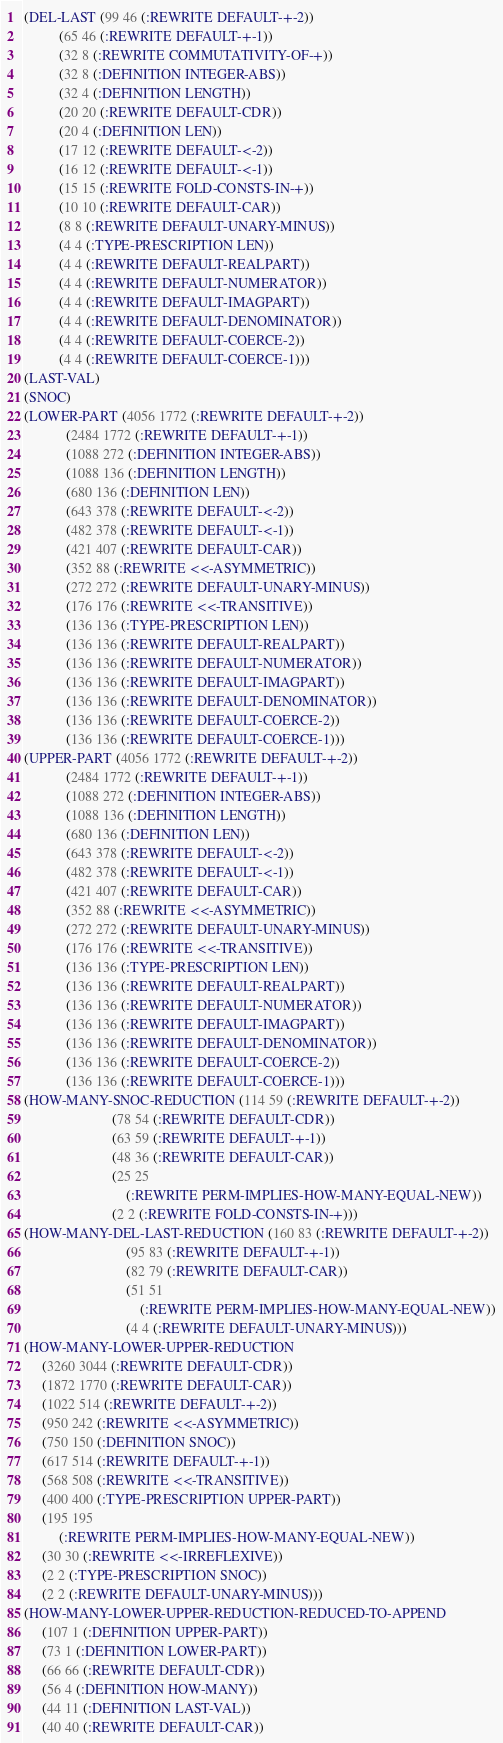Convert code to text. <code><loc_0><loc_0><loc_500><loc_500><_Lisp_>(DEL-LAST (99 46 (:REWRITE DEFAULT-+-2))
          (65 46 (:REWRITE DEFAULT-+-1))
          (32 8 (:REWRITE COMMUTATIVITY-OF-+))
          (32 8 (:DEFINITION INTEGER-ABS))
          (32 4 (:DEFINITION LENGTH))
          (20 20 (:REWRITE DEFAULT-CDR))
          (20 4 (:DEFINITION LEN))
          (17 12 (:REWRITE DEFAULT-<-2))
          (16 12 (:REWRITE DEFAULT-<-1))
          (15 15 (:REWRITE FOLD-CONSTS-IN-+))
          (10 10 (:REWRITE DEFAULT-CAR))
          (8 8 (:REWRITE DEFAULT-UNARY-MINUS))
          (4 4 (:TYPE-PRESCRIPTION LEN))
          (4 4 (:REWRITE DEFAULT-REALPART))
          (4 4 (:REWRITE DEFAULT-NUMERATOR))
          (4 4 (:REWRITE DEFAULT-IMAGPART))
          (4 4 (:REWRITE DEFAULT-DENOMINATOR))
          (4 4 (:REWRITE DEFAULT-COERCE-2))
          (4 4 (:REWRITE DEFAULT-COERCE-1)))
(LAST-VAL)
(SNOC)
(LOWER-PART (4056 1772 (:REWRITE DEFAULT-+-2))
            (2484 1772 (:REWRITE DEFAULT-+-1))
            (1088 272 (:DEFINITION INTEGER-ABS))
            (1088 136 (:DEFINITION LENGTH))
            (680 136 (:DEFINITION LEN))
            (643 378 (:REWRITE DEFAULT-<-2))
            (482 378 (:REWRITE DEFAULT-<-1))
            (421 407 (:REWRITE DEFAULT-CAR))
            (352 88 (:REWRITE <<-ASYMMETRIC))
            (272 272 (:REWRITE DEFAULT-UNARY-MINUS))
            (176 176 (:REWRITE <<-TRANSITIVE))
            (136 136 (:TYPE-PRESCRIPTION LEN))
            (136 136 (:REWRITE DEFAULT-REALPART))
            (136 136 (:REWRITE DEFAULT-NUMERATOR))
            (136 136 (:REWRITE DEFAULT-IMAGPART))
            (136 136 (:REWRITE DEFAULT-DENOMINATOR))
            (136 136 (:REWRITE DEFAULT-COERCE-2))
            (136 136 (:REWRITE DEFAULT-COERCE-1)))
(UPPER-PART (4056 1772 (:REWRITE DEFAULT-+-2))
            (2484 1772 (:REWRITE DEFAULT-+-1))
            (1088 272 (:DEFINITION INTEGER-ABS))
            (1088 136 (:DEFINITION LENGTH))
            (680 136 (:DEFINITION LEN))
            (643 378 (:REWRITE DEFAULT-<-2))
            (482 378 (:REWRITE DEFAULT-<-1))
            (421 407 (:REWRITE DEFAULT-CAR))
            (352 88 (:REWRITE <<-ASYMMETRIC))
            (272 272 (:REWRITE DEFAULT-UNARY-MINUS))
            (176 176 (:REWRITE <<-TRANSITIVE))
            (136 136 (:TYPE-PRESCRIPTION LEN))
            (136 136 (:REWRITE DEFAULT-REALPART))
            (136 136 (:REWRITE DEFAULT-NUMERATOR))
            (136 136 (:REWRITE DEFAULT-IMAGPART))
            (136 136 (:REWRITE DEFAULT-DENOMINATOR))
            (136 136 (:REWRITE DEFAULT-COERCE-2))
            (136 136 (:REWRITE DEFAULT-COERCE-1)))
(HOW-MANY-SNOC-REDUCTION (114 59 (:REWRITE DEFAULT-+-2))
                         (78 54 (:REWRITE DEFAULT-CDR))
                         (63 59 (:REWRITE DEFAULT-+-1))
                         (48 36 (:REWRITE DEFAULT-CAR))
                         (25 25
                             (:REWRITE PERM-IMPLIES-HOW-MANY-EQUAL-NEW))
                         (2 2 (:REWRITE FOLD-CONSTS-IN-+)))
(HOW-MANY-DEL-LAST-REDUCTION (160 83 (:REWRITE DEFAULT-+-2))
                             (95 83 (:REWRITE DEFAULT-+-1))
                             (82 79 (:REWRITE DEFAULT-CAR))
                             (51 51
                                 (:REWRITE PERM-IMPLIES-HOW-MANY-EQUAL-NEW))
                             (4 4 (:REWRITE DEFAULT-UNARY-MINUS)))
(HOW-MANY-LOWER-UPPER-REDUCTION
     (3260 3044 (:REWRITE DEFAULT-CDR))
     (1872 1770 (:REWRITE DEFAULT-CAR))
     (1022 514 (:REWRITE DEFAULT-+-2))
     (950 242 (:REWRITE <<-ASYMMETRIC))
     (750 150 (:DEFINITION SNOC))
     (617 514 (:REWRITE DEFAULT-+-1))
     (568 508 (:REWRITE <<-TRANSITIVE))
     (400 400 (:TYPE-PRESCRIPTION UPPER-PART))
     (195 195
          (:REWRITE PERM-IMPLIES-HOW-MANY-EQUAL-NEW))
     (30 30 (:REWRITE <<-IRREFLEXIVE))
     (2 2 (:TYPE-PRESCRIPTION SNOC))
     (2 2 (:REWRITE DEFAULT-UNARY-MINUS)))
(HOW-MANY-LOWER-UPPER-REDUCTION-REDUCED-TO-APPEND
     (107 1 (:DEFINITION UPPER-PART))
     (73 1 (:DEFINITION LOWER-PART))
     (66 66 (:REWRITE DEFAULT-CDR))
     (56 4 (:DEFINITION HOW-MANY))
     (44 11 (:DEFINITION LAST-VAL))
     (40 40 (:REWRITE DEFAULT-CAR))</code> 